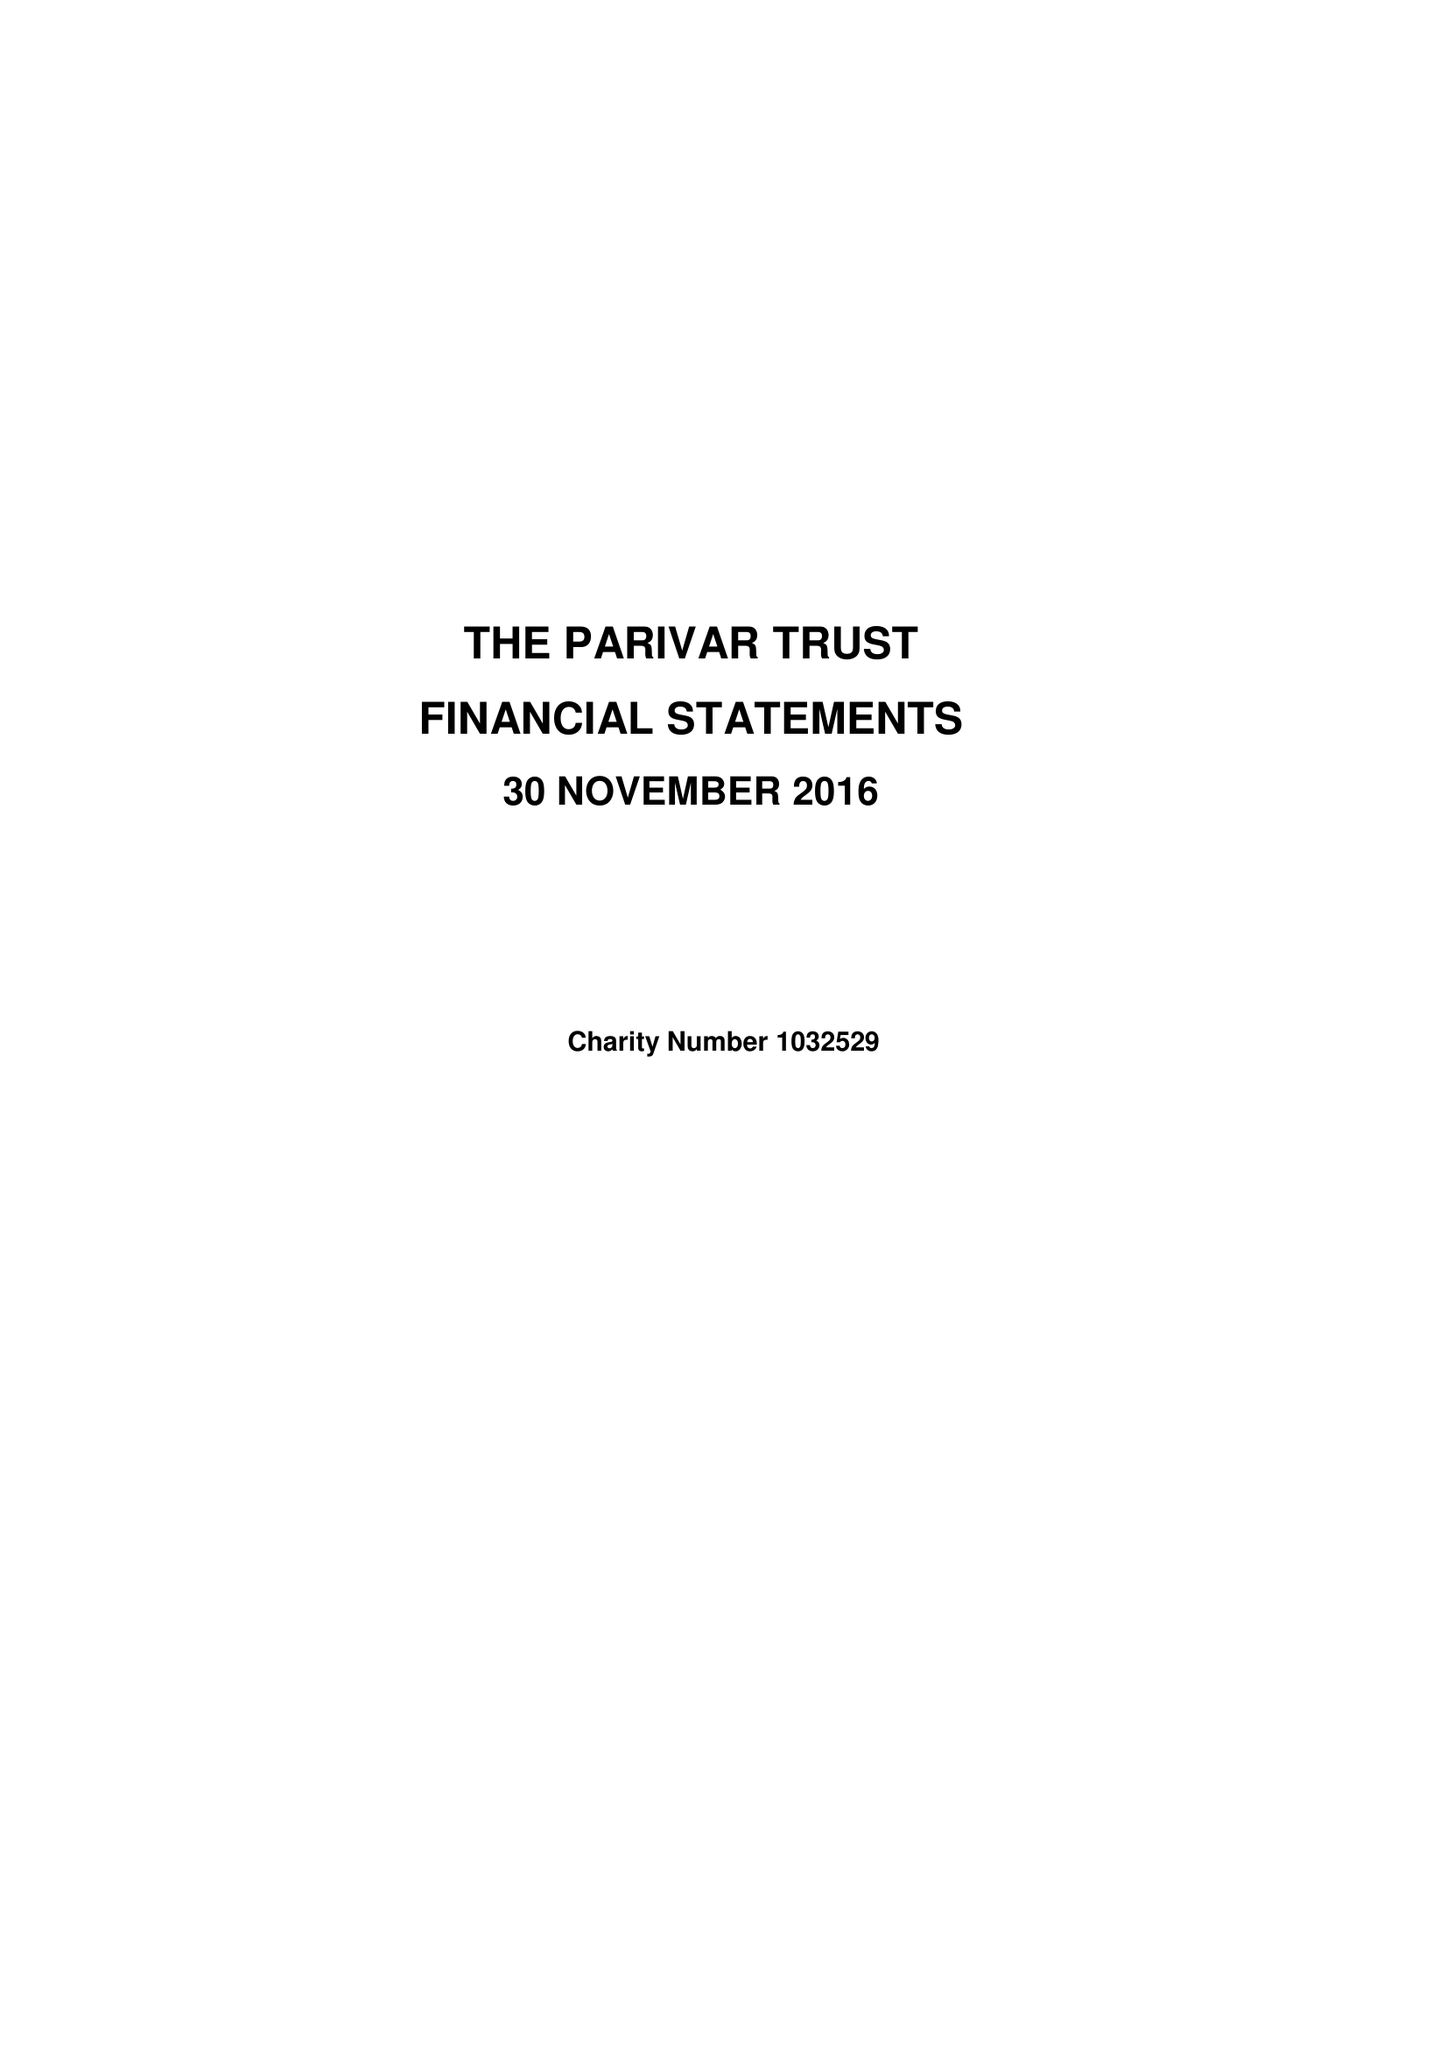What is the value for the charity_name?
Answer the question using a single word or phrase. The Parivar Trust 